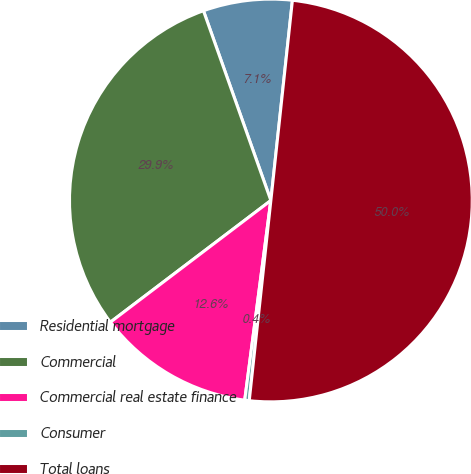Convert chart. <chart><loc_0><loc_0><loc_500><loc_500><pie_chart><fcel>Residential mortgage<fcel>Commercial<fcel>Commercial real estate finance<fcel>Consumer<fcel>Total loans<nl><fcel>7.14%<fcel>29.89%<fcel>12.6%<fcel>0.36%<fcel>50.0%<nl></chart> 